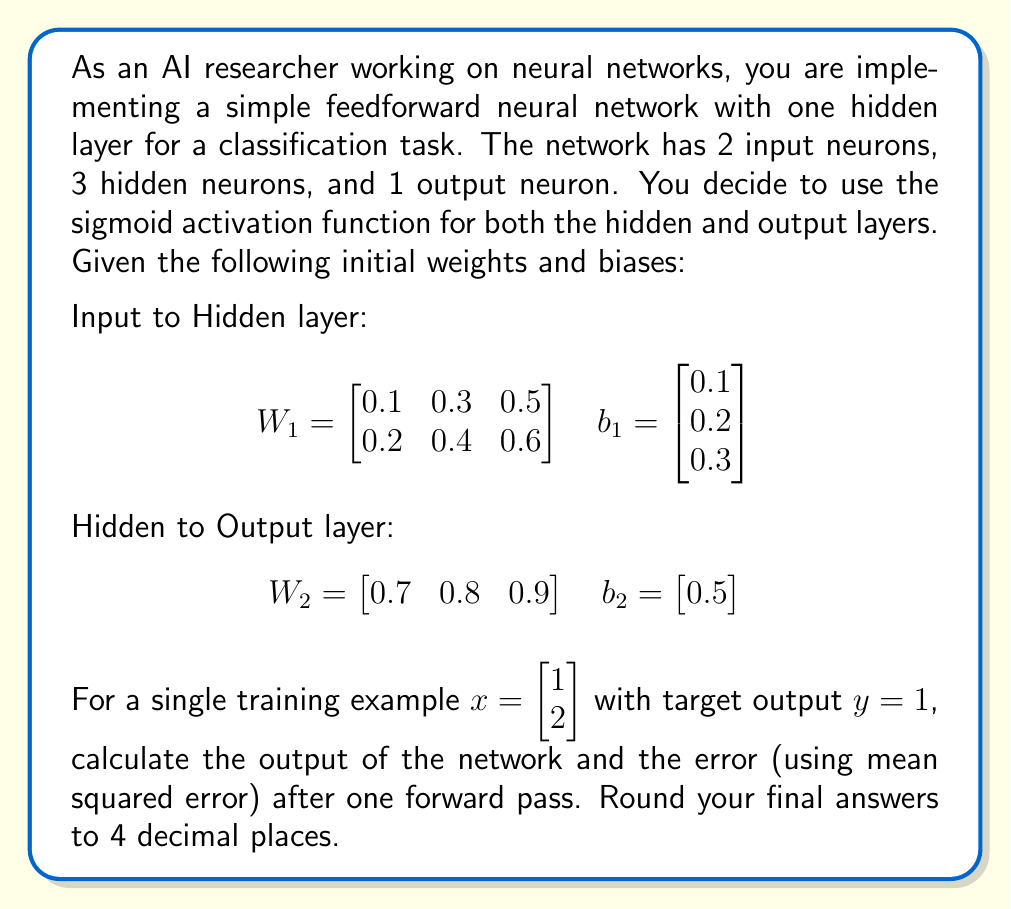Can you answer this question? Let's break this down step-by-step:

1. Forward pass through the hidden layer:
   $z_1 = W_1^T x + b_1$
   $z_1 = \begin{bmatrix} 0.1 & 0.2 \\ 0.3 & 0.4 \\ 0.5 & 0.6 \end{bmatrix} \begin{bmatrix} 1 \\ 2 \end{bmatrix} + \begin{bmatrix} 0.1 \\ 0.2 \\ 0.3 \end{bmatrix}$
   $z_1 = \begin{bmatrix} 0.5 \\ 1.1 \\ 1.7 \end{bmatrix}$

2. Apply sigmoid activation to hidden layer:
   $a_1 = \sigma(z_1)$, where $\sigma(x) = \frac{1}{1 + e^{-x}}$
   $a_1 = \begin{bmatrix} \sigma(0.5) \\ \sigma(1.1) \\ \sigma(1.7) \end{bmatrix} = \begin{bmatrix} 0.6225 \\ 0.7503 \\ 0.8458 \end{bmatrix}$

3. Forward pass through the output layer:
   $z_2 = W_2 a_1 + b_2$
   $z_2 = \begin{bmatrix} 0.7 & 0.8 & 0.9 \end{bmatrix} \begin{bmatrix} 0.6225 \\ 0.7503 \\ 0.8458 \end{bmatrix} + \begin{bmatrix} 0.5 \end{bmatrix}$
   $z_2 = 1.9922$

4. Apply sigmoid activation to output layer:
   $a_2 = \sigma(z_2) = \sigma(1.9922) = 0.8802$

5. Calculate the error using mean squared error (MSE):
   $E = \frac{1}{2}(y - a_2)^2 = \frac{1}{2}(1 - 0.8802)^2 = 0.0072$

Therefore, the output of the network after one forward pass is 0.8802, and the error is 0.0072.
Answer: Output: 0.8802
Error: 0.0072 